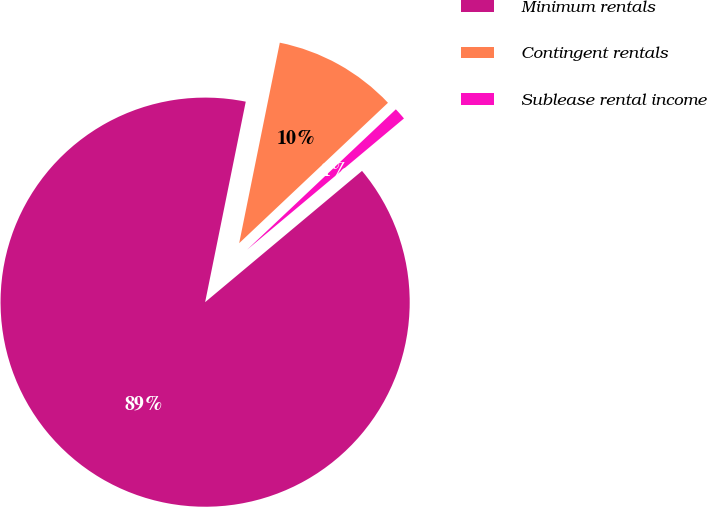Convert chart to OTSL. <chart><loc_0><loc_0><loc_500><loc_500><pie_chart><fcel>Minimum rentals<fcel>Contingent rentals<fcel>Sublease rental income<nl><fcel>89.27%<fcel>9.78%<fcel>0.95%<nl></chart> 